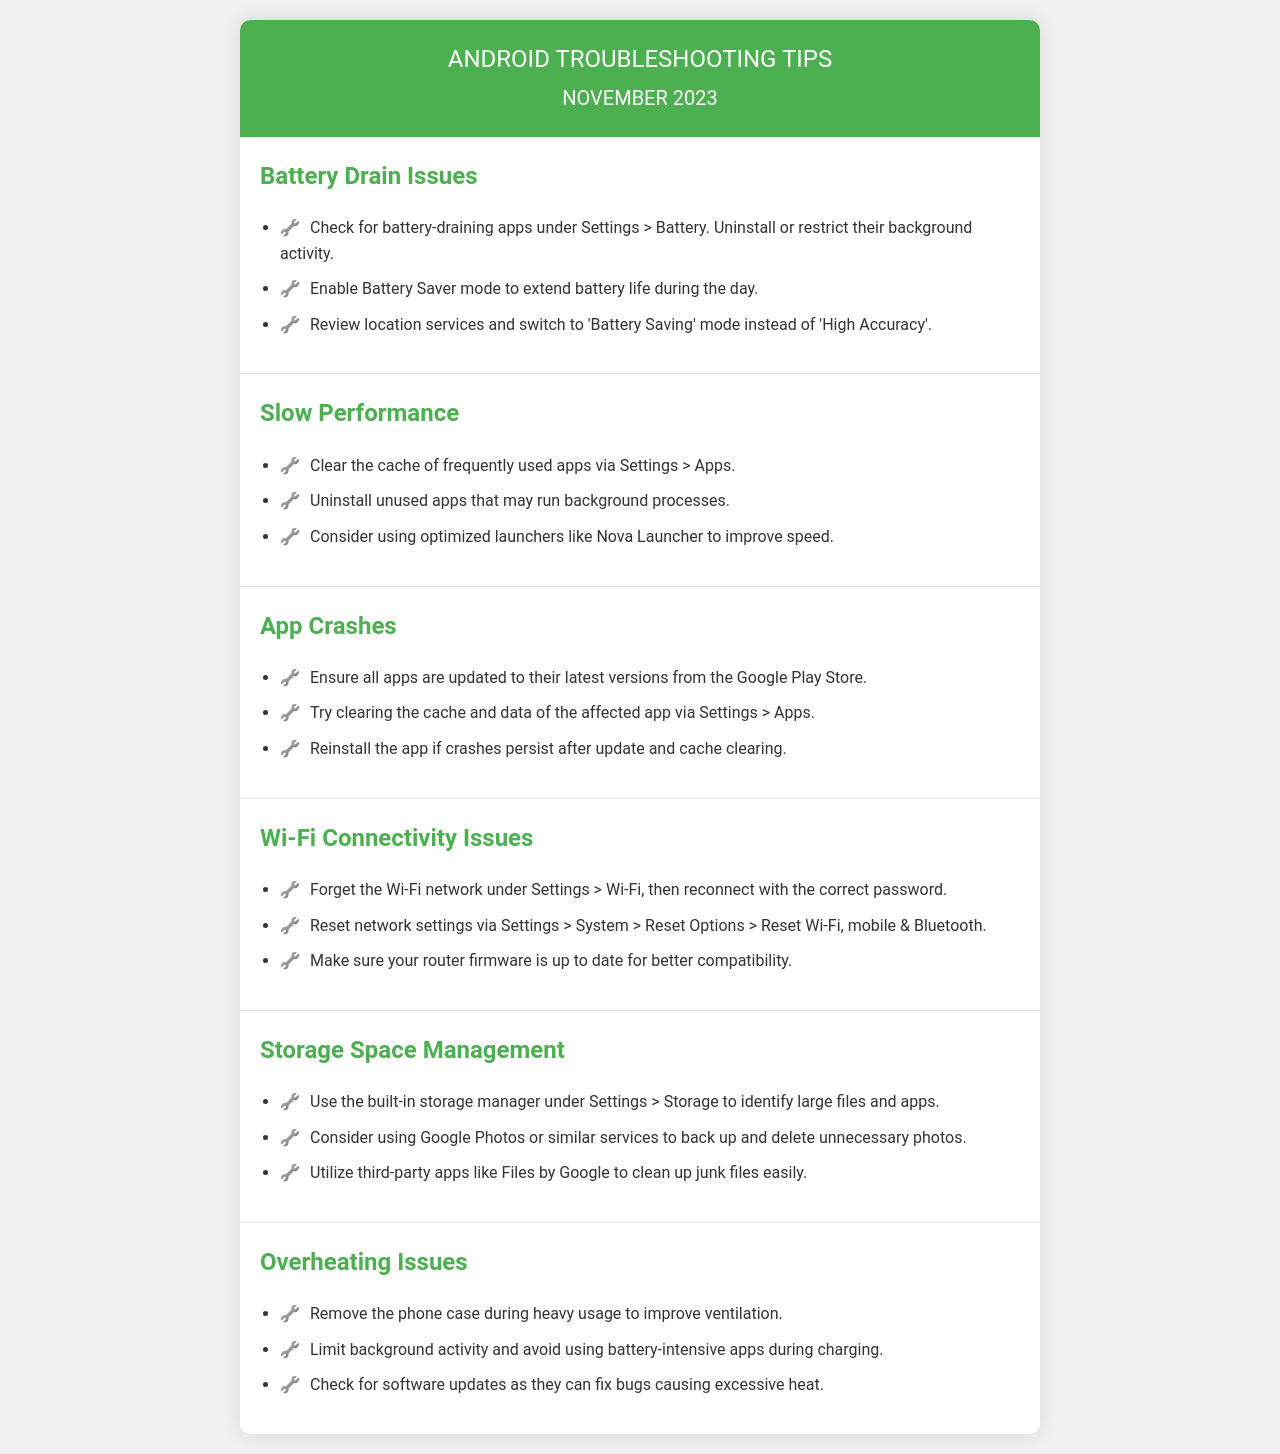What is the title of the document? The title of the document is indicated in the <title> tag of the HTML, which is "Android Troubleshooting Tips - November 2023."
Answer: Android Troubleshooting Tips - November 2023 How many topics are covered in the document? The document contains six distinct topics related to troubleshooting Android issues.
Answer: 6 What is the first troubleshooting tip under Battery Drain Issues? The first tip listed under Battery Drain Issues advises checking for battery-draining apps under Settings > Battery.
Answer: Check for battery-draining apps under Settings > Battery What should you do if apps continue to crash after clearing cache? The document suggests reinstalling the app if crashes persist after updating and clearing cache and data.
Answer: Reinstall the app What is one way to manage storage space on an Android device? The document recommends using the built-in storage manager under Settings > Storage to identify large files and apps.
Answer: Use the built-in storage manager under Settings > Storage What can be done to improve Wi-Fi connectivity? A recommended action is to forget the Wi-Fi network and then reconnect with the correct password.
Answer: Forget the Wi-Fi network and reconnect What is a potential reason for overheating issues according to the document? One reason for overheating mentioned is to avoid using battery-intensive apps during charging.
Answer: Avoid using battery-intensive apps during charging What is the suggested mode for location services to save battery? The document advises switching the location services to 'Battery Saving' mode instead of 'High Accuracy.'
Answer: Battery Saving mode How can you stop apps from running in the background to improve performance? The document suggests uninstalling unused apps that may run background processes.
Answer: Uninstall unused apps 